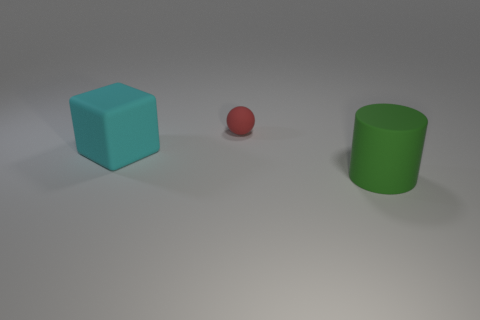Are there the same number of cylinders behind the large rubber block and red matte things that are in front of the red thing? Yes, there appears to be an equal number of cylindrical objects positioned behind the larger blue cube as there are objects in front of the red sphere. By observing the arrangement, we notice one cylindrical green object at the back, which matches the single red sphere at the front, creating a balanced visual. 